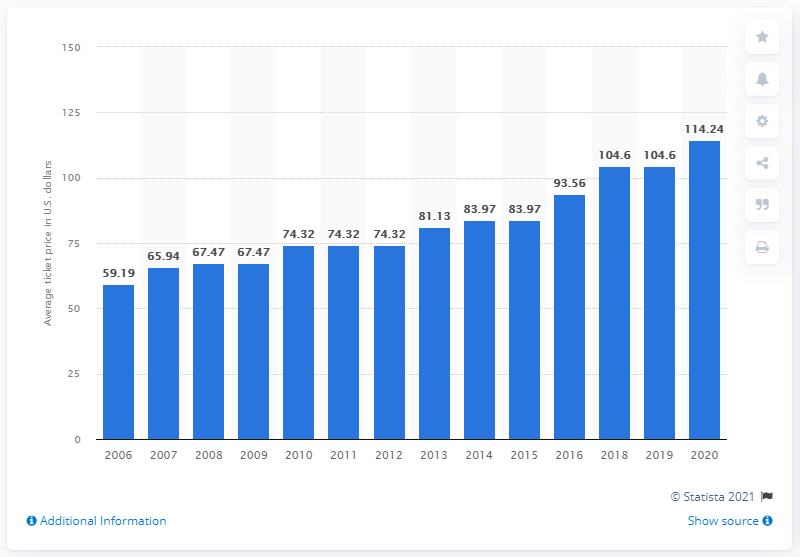Draw attention to some important aspects in this diagram. In 2020, the average ticket price for Steelers games was 114.24 USD. 